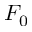Convert formula to latex. <formula><loc_0><loc_0><loc_500><loc_500>F _ { 0 }</formula> 